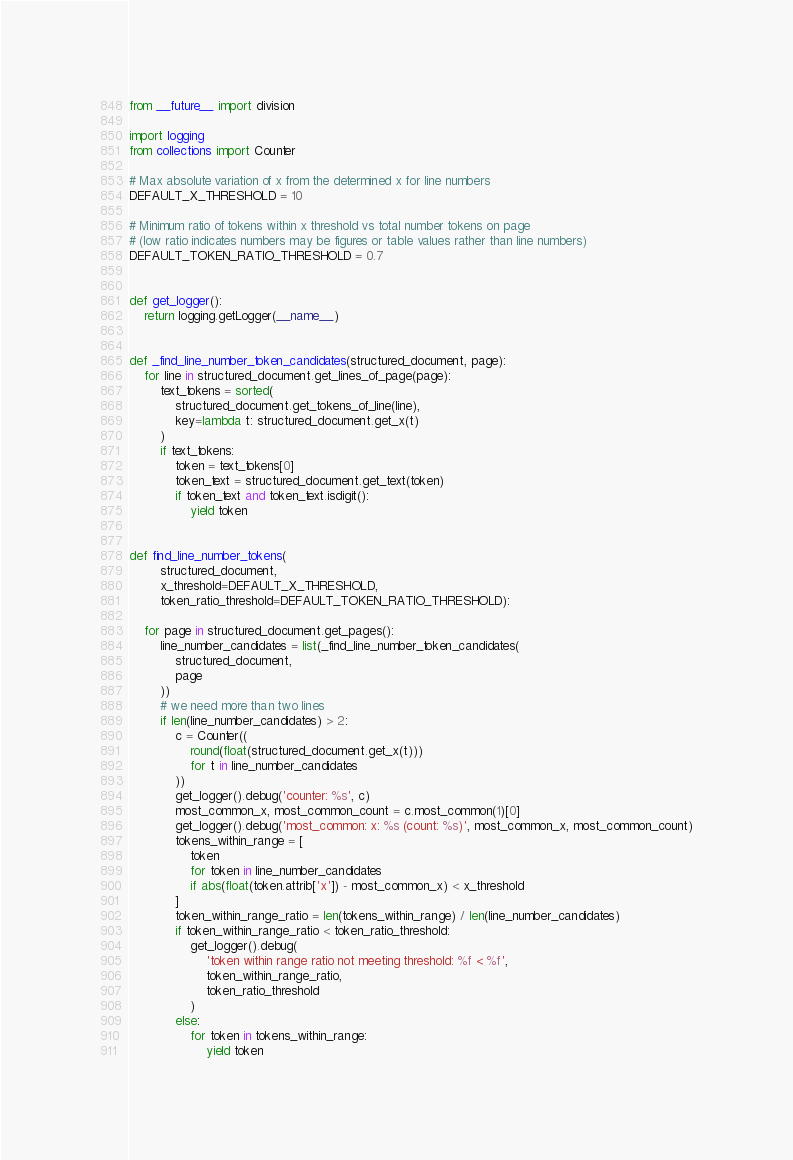<code> <loc_0><loc_0><loc_500><loc_500><_Python_>from __future__ import division

import logging
from collections import Counter

# Max absolute variation of x from the determined x for line numbers
DEFAULT_X_THRESHOLD = 10

# Minimum ratio of tokens within x threshold vs total number tokens on page
# (low ratio indicates numbers may be figures or table values rather than line numbers)
DEFAULT_TOKEN_RATIO_THRESHOLD = 0.7


def get_logger():
    return logging.getLogger(__name__)


def _find_line_number_token_candidates(structured_document, page):
    for line in structured_document.get_lines_of_page(page):
        text_tokens = sorted(
            structured_document.get_tokens_of_line(line),
            key=lambda t: structured_document.get_x(t)
        )
        if text_tokens:
            token = text_tokens[0]
            token_text = structured_document.get_text(token)
            if token_text and token_text.isdigit():
                yield token


def find_line_number_tokens(
        structured_document,
        x_threshold=DEFAULT_X_THRESHOLD,
        token_ratio_threshold=DEFAULT_TOKEN_RATIO_THRESHOLD):

    for page in structured_document.get_pages():
        line_number_candidates = list(_find_line_number_token_candidates(
            structured_document,
            page
        ))
        # we need more than two lines
        if len(line_number_candidates) > 2:
            c = Counter((
                round(float(structured_document.get_x(t)))
                for t in line_number_candidates
            ))
            get_logger().debug('counter: %s', c)
            most_common_x, most_common_count = c.most_common(1)[0]
            get_logger().debug('most_common: x: %s (count: %s)', most_common_x, most_common_count)
            tokens_within_range = [
                token
                for token in line_number_candidates
                if abs(float(token.attrib['x']) - most_common_x) < x_threshold
            ]
            token_within_range_ratio = len(tokens_within_range) / len(line_number_candidates)
            if token_within_range_ratio < token_ratio_threshold:
                get_logger().debug(
                    'token within range ratio not meeting threshold: %f < %f',
                    token_within_range_ratio,
                    token_ratio_threshold
                )
            else:
                for token in tokens_within_range:
                    yield token
</code> 